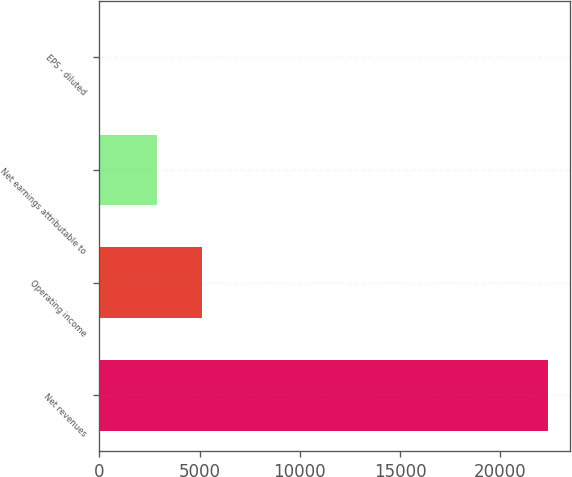Convert chart. <chart><loc_0><loc_0><loc_500><loc_500><bar_chart><fcel>Net revenues<fcel>Operating income<fcel>Net earnings attributable to<fcel>EPS - diluted<nl><fcel>22386.8<fcel>5123.18<fcel>2884.7<fcel>1.97<nl></chart> 